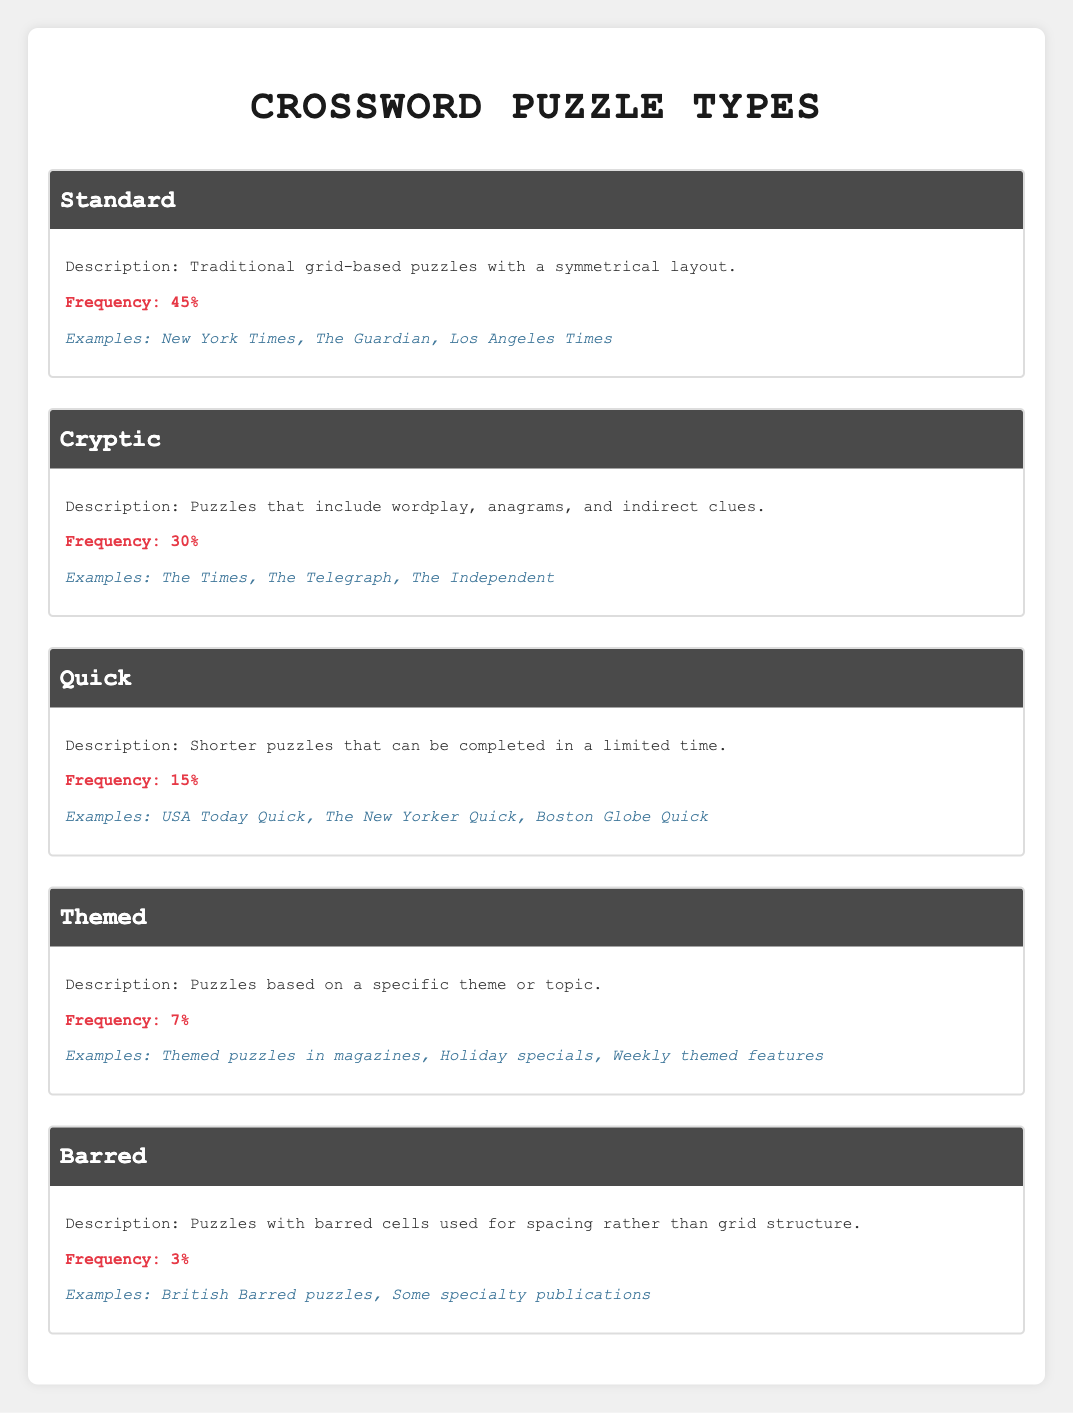What is the frequency of Standard crossword puzzles? The table shows that the frequency of Standard crossword puzzles is listed as 45%.
Answer: 45% Which type of crossword puzzle has the least frequency of use? The least frequency of use, according to the table, is Barred crossword puzzles with a frequency of 3%.
Answer: Barred How many types of crossword puzzles have a frequency of 10% or more? The types with a frequency of 10% or more are Standard (45%), Cryptic (30%), and Quick (15%). Thus, there are three types.
Answer: 3 What are the examples given for Themed crossword puzzles? The examples listed for Themed crossword puzzles are "Themed puzzles in magazines", "Holiday specials", and "Weekly themed features".
Answer: Themed puzzles in magazines, Holiday specials, Weekly themed features Is it true that Quick puzzles have a higher frequency than Themed puzzles? Yes, Quick puzzles have a frequency of 15%, while Themed puzzles only have a frequency of 7%. Therefore, Quick puzzles do have a higher frequency.
Answer: Yes If you combine the frequencies of Cryptic and Themed puzzles, what is the total? Combining the frequencies: Cryptic is 30% and Themed is 7%, so 30 + 7 = 37%.
Answer: 37% Which type of crossword puzzle is most likely found in the New York Times? According to the table, the New York Times is an example of Standard crossword puzzles, making it the most likely found there.
Answer: Standard Are there more examples listed for Standard puzzles than for Barred puzzles? Yes, Standard puzzles have three examples listed while Barred puzzles have only two examples listed.
Answer: Yes 